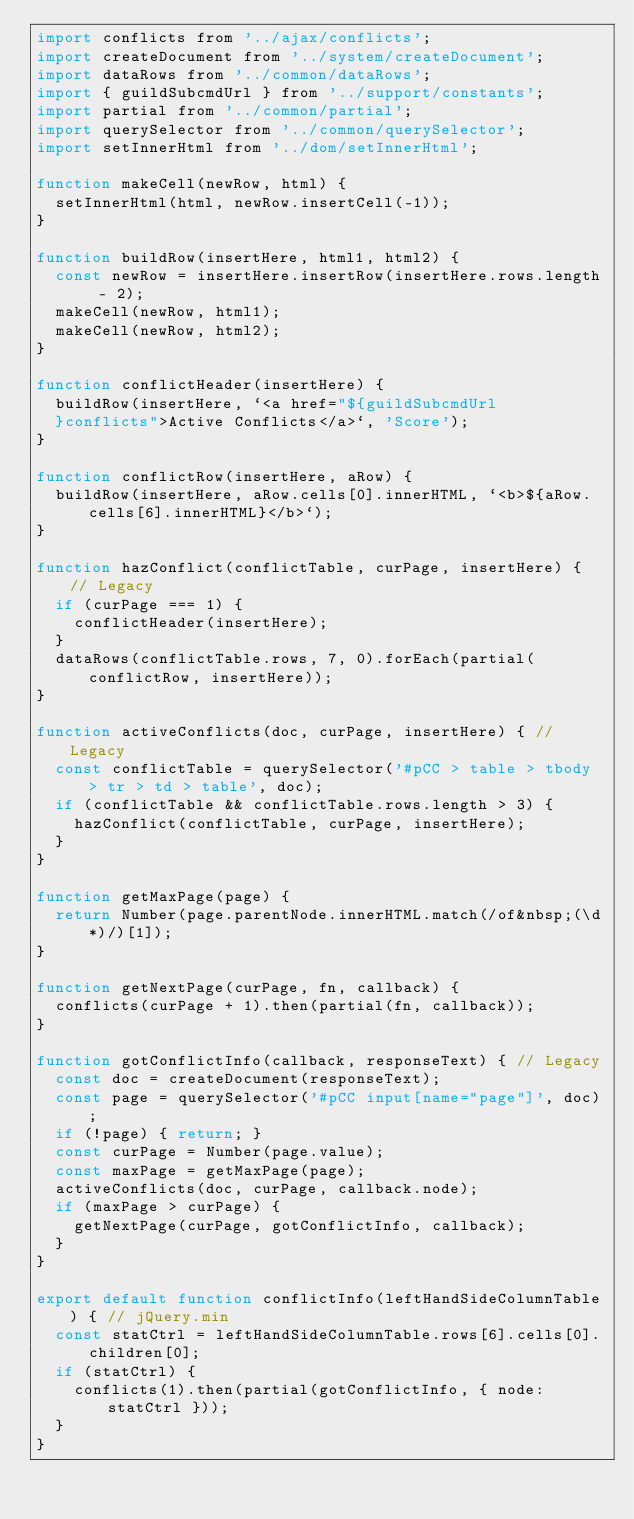<code> <loc_0><loc_0><loc_500><loc_500><_JavaScript_>import conflicts from '../ajax/conflicts';
import createDocument from '../system/createDocument';
import dataRows from '../common/dataRows';
import { guildSubcmdUrl } from '../support/constants';
import partial from '../common/partial';
import querySelector from '../common/querySelector';
import setInnerHtml from '../dom/setInnerHtml';

function makeCell(newRow, html) {
  setInnerHtml(html, newRow.insertCell(-1));
}

function buildRow(insertHere, html1, html2) {
  const newRow = insertHere.insertRow(insertHere.rows.length - 2);
  makeCell(newRow, html1);
  makeCell(newRow, html2);
}

function conflictHeader(insertHere) {
  buildRow(insertHere, `<a href="${guildSubcmdUrl
  }conflicts">Active Conflicts</a>`, 'Score');
}

function conflictRow(insertHere, aRow) {
  buildRow(insertHere, aRow.cells[0].innerHTML, `<b>${aRow.cells[6].innerHTML}</b>`);
}

function hazConflict(conflictTable, curPage, insertHere) { // Legacy
  if (curPage === 1) {
    conflictHeader(insertHere);
  }
  dataRows(conflictTable.rows, 7, 0).forEach(partial(conflictRow, insertHere));
}

function activeConflicts(doc, curPage, insertHere) { // Legacy
  const conflictTable = querySelector('#pCC > table > tbody > tr > td > table', doc);
  if (conflictTable && conflictTable.rows.length > 3) {
    hazConflict(conflictTable, curPage, insertHere);
  }
}

function getMaxPage(page) {
  return Number(page.parentNode.innerHTML.match(/of&nbsp;(\d*)/)[1]);
}

function getNextPage(curPage, fn, callback) {
  conflicts(curPage + 1).then(partial(fn, callback));
}

function gotConflictInfo(callback, responseText) { // Legacy
  const doc = createDocument(responseText);
  const page = querySelector('#pCC input[name="page"]', doc);
  if (!page) { return; }
  const curPage = Number(page.value);
  const maxPage = getMaxPage(page);
  activeConflicts(doc, curPage, callback.node);
  if (maxPage > curPage) {
    getNextPage(curPage, gotConflictInfo, callback);
  }
}

export default function conflictInfo(leftHandSideColumnTable) { // jQuery.min
  const statCtrl = leftHandSideColumnTable.rows[6].cells[0].children[0];
  if (statCtrl) {
    conflicts(1).then(partial(gotConflictInfo, { node: statCtrl }));
  }
}
</code> 